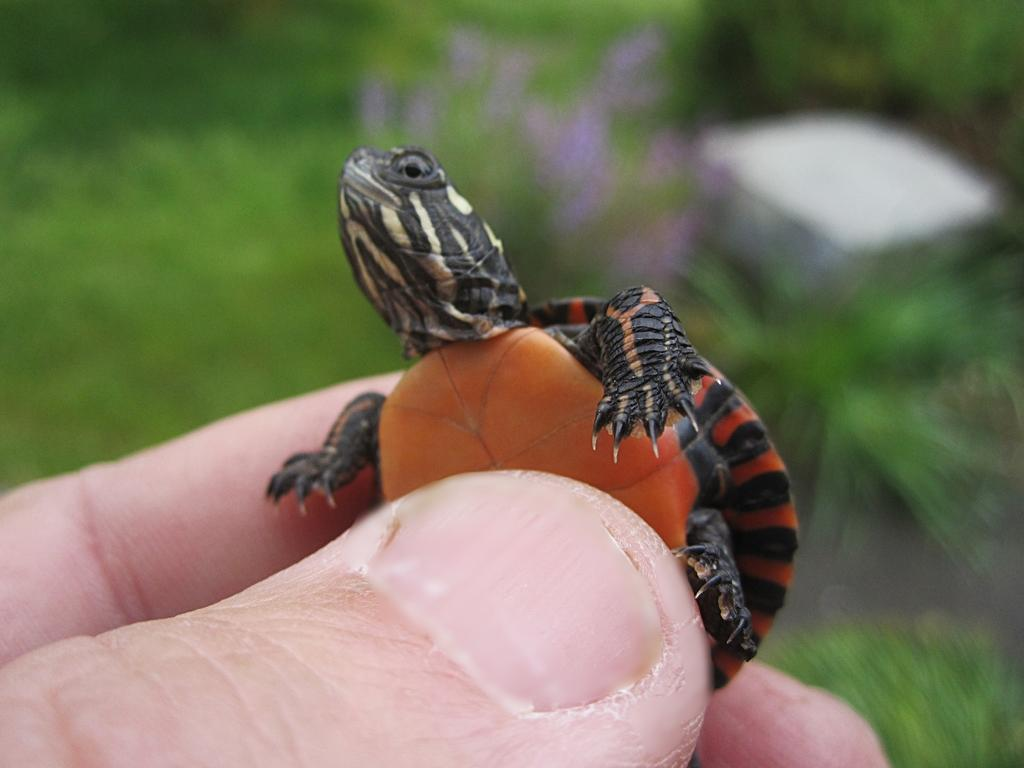What is being held in the foreground of the image? Persons' fingers are holding a turtle in the foreground of the image. What can be seen in the background of the image? There are plants in the background of the image. What type of vegetation is visible in the image? Grass is visible in the image. How many houses can be seen shaking in the image? There are no houses present in the image, and therefore no houses can be seen shaking. What type of joke is being told by the turtle in the image? There is no joke being told by the turtle in the image, as it is a living creature and not capable of telling jokes. 